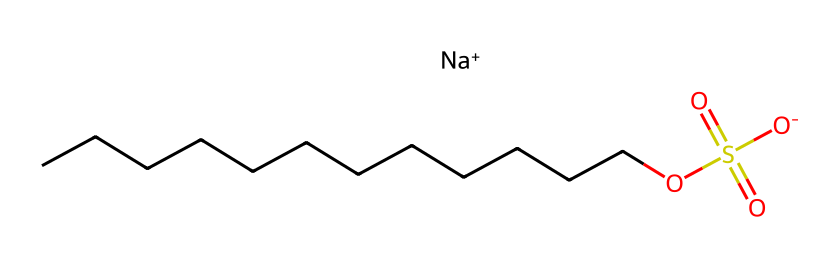What is the molecular formula of sodium lauryl sulfate? The SMILES representation can be translated to identify the constituent atoms: there are 12 carbon (C) atoms, 25 hydrogen (H) atoms, 1 sulfur (S) atom, 4 oxygen (O) atoms, and 1 sodium (Na) atom, thus forming the molecular formula C12H25NaO4S.
Answer: C12H25NaO4S How many carbon atoms are present in sodium lauryl sulfate? By analyzing the SMILES, we count the 'C' atoms in the aliphatic chain before the sulfate group; there are 12 carbon atoms.
Answer: 12 What type of bond exists between the sulfur and the oxygen atoms in the sulfate group? The SMILES indicates that sulfur (S) is connected to four oxygen (O) atoms, with two of these forming double bonds, indicating that the connections include both double bonds (O=S) and single bonds (S-O), characterizing a sulfonate group.
Answer: double bond How does sodium lauryl sulfate interact with water? Sodium lauryl sulfate has a hydrophilic (water-attracting) head due to the sulfate moiety and a hydrophobic (water-repelling) tail due to the long carbon chain; this amphiphilic nature allows it to reduce surface tension and act as a detergent.
Answer: amphiphilic What is the role of sodium in sodium lauryl sulfate? In the provided SMILES, the sodium (Na+) ion acts as a counterion to the negatively charged sulfate group, which is essential for the stability and solubility of the detergent in solutions.
Answer: counterion What functional groups are present in sodium lauryl sulfate? The primary functional group in sodium lauryl sulfate visible in the SMILES is the sulfate group (-OS(=O)(=O)[O-]), characterized by sulfur bonded to four oxygens. This indicates it is a sulfate, which is typical in anionic detergents.
Answer: sulfate group 